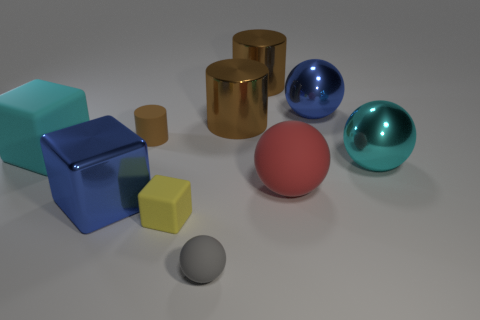Can you tell me which objects in the image are reflective? Certainly! The objects that appear reflective include the large blue cube, the gold cylinder, the blue sphere, and the teal sphere. These objects exhibit specular highlights suggesting a level of reflectivity. 